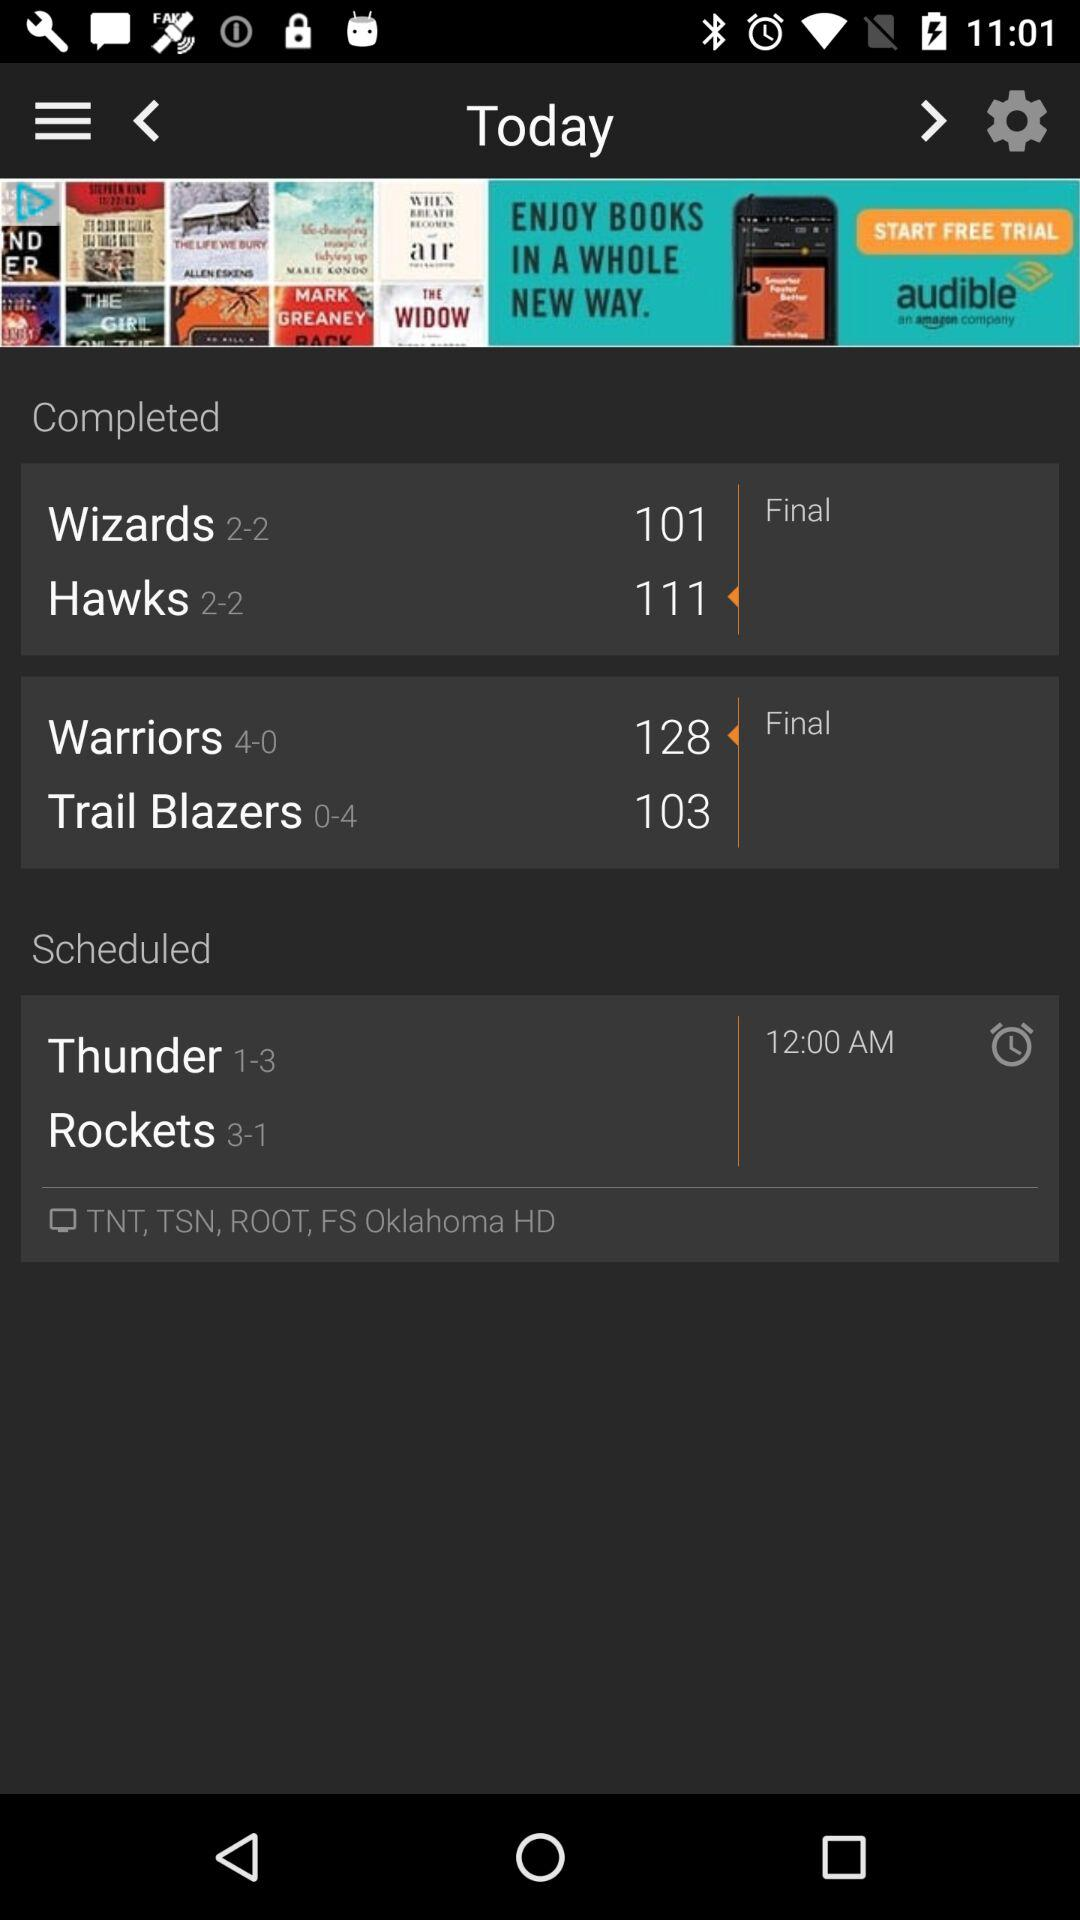What is the count of the warriors? The count of the warriors is 4-0. 